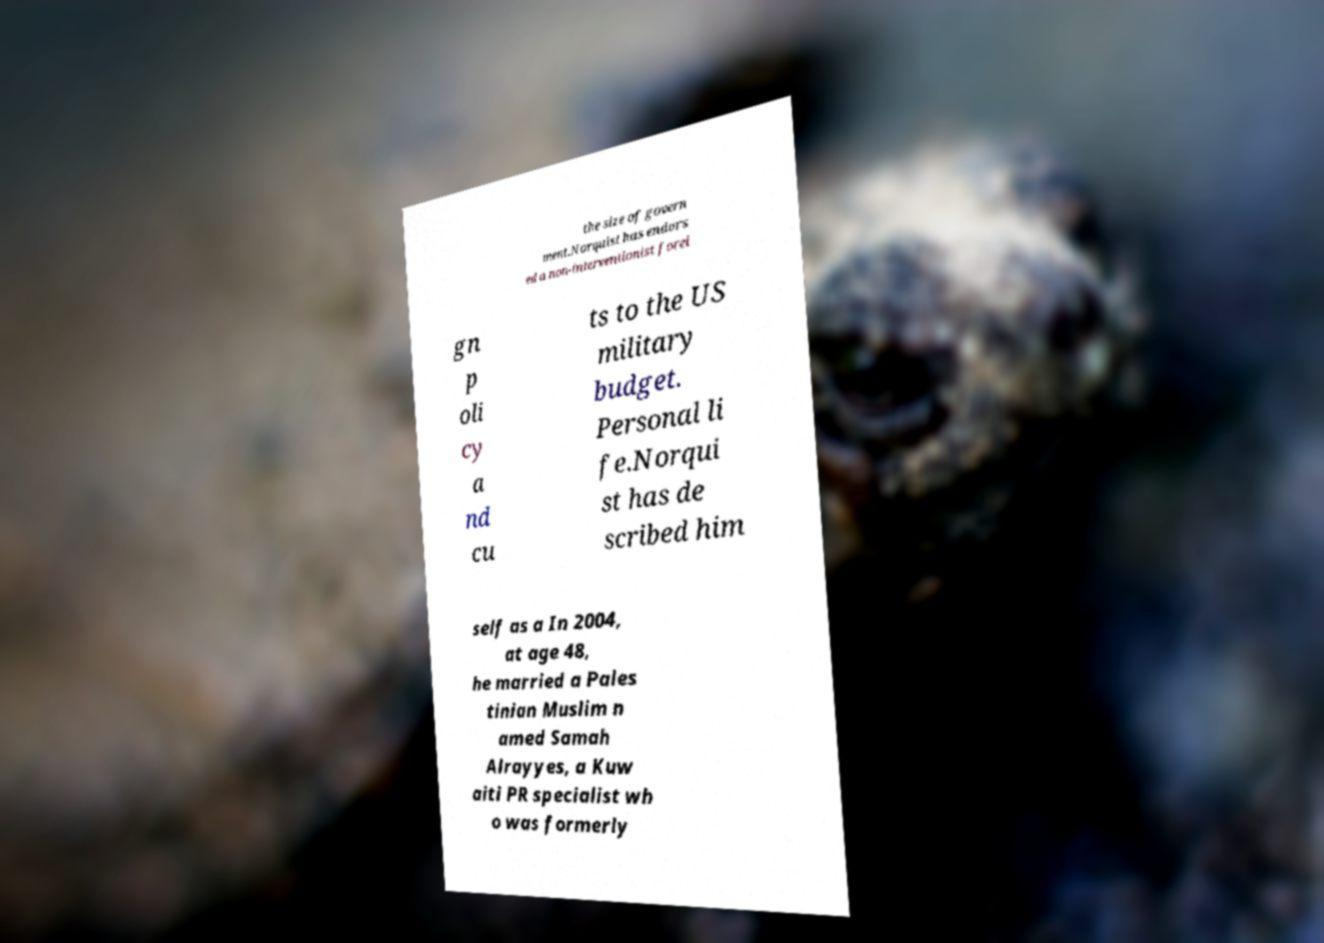Could you assist in decoding the text presented in this image and type it out clearly? the size of govern ment.Norquist has endors ed a non-interventionist forei gn p oli cy a nd cu ts to the US military budget. Personal li fe.Norqui st has de scribed him self as a In 2004, at age 48, he married a Pales tinian Muslim n amed Samah Alrayyes, a Kuw aiti PR specialist wh o was formerly 